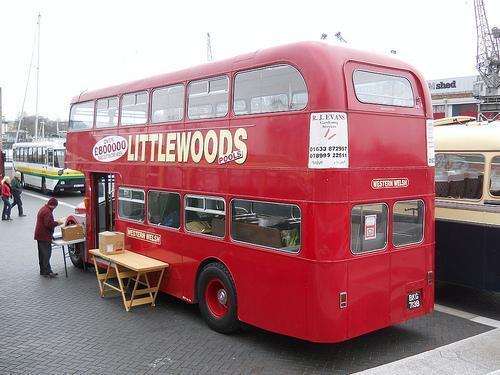How many boxes are on the tan table?
Give a very brief answer. 1. How many levels does the red bus have?
Give a very brief answer. 2. How many people are sitting at the table?
Give a very brief answer. 0. 